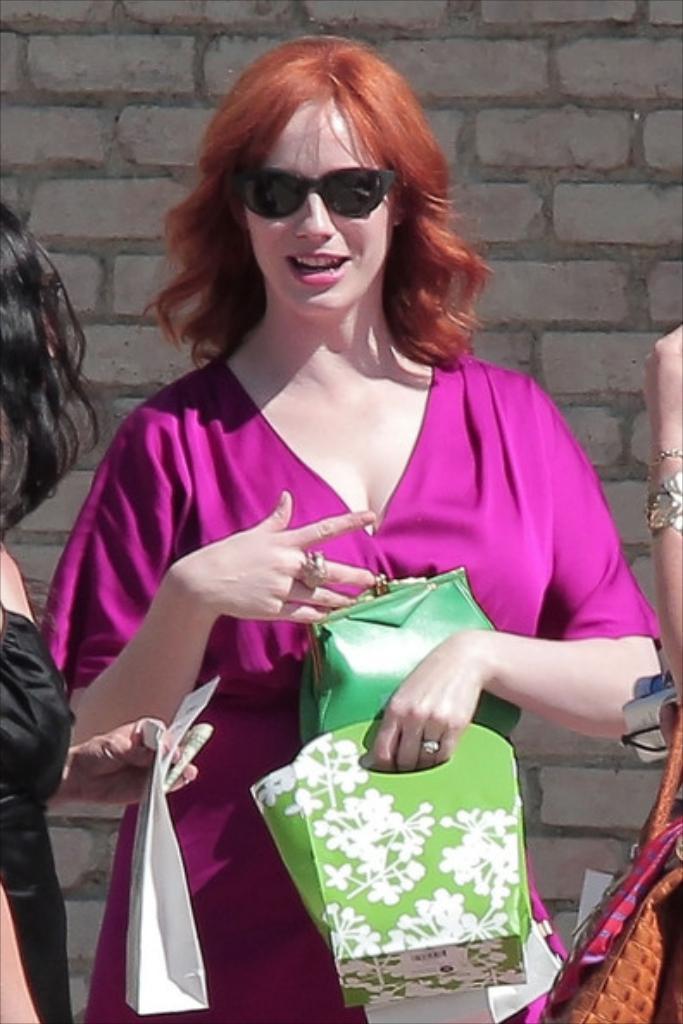Describe this image in one or two sentences. There is a woman standing here wearing a pink dress and spectacles. There are some bags in her hand. In the background there is wall. 